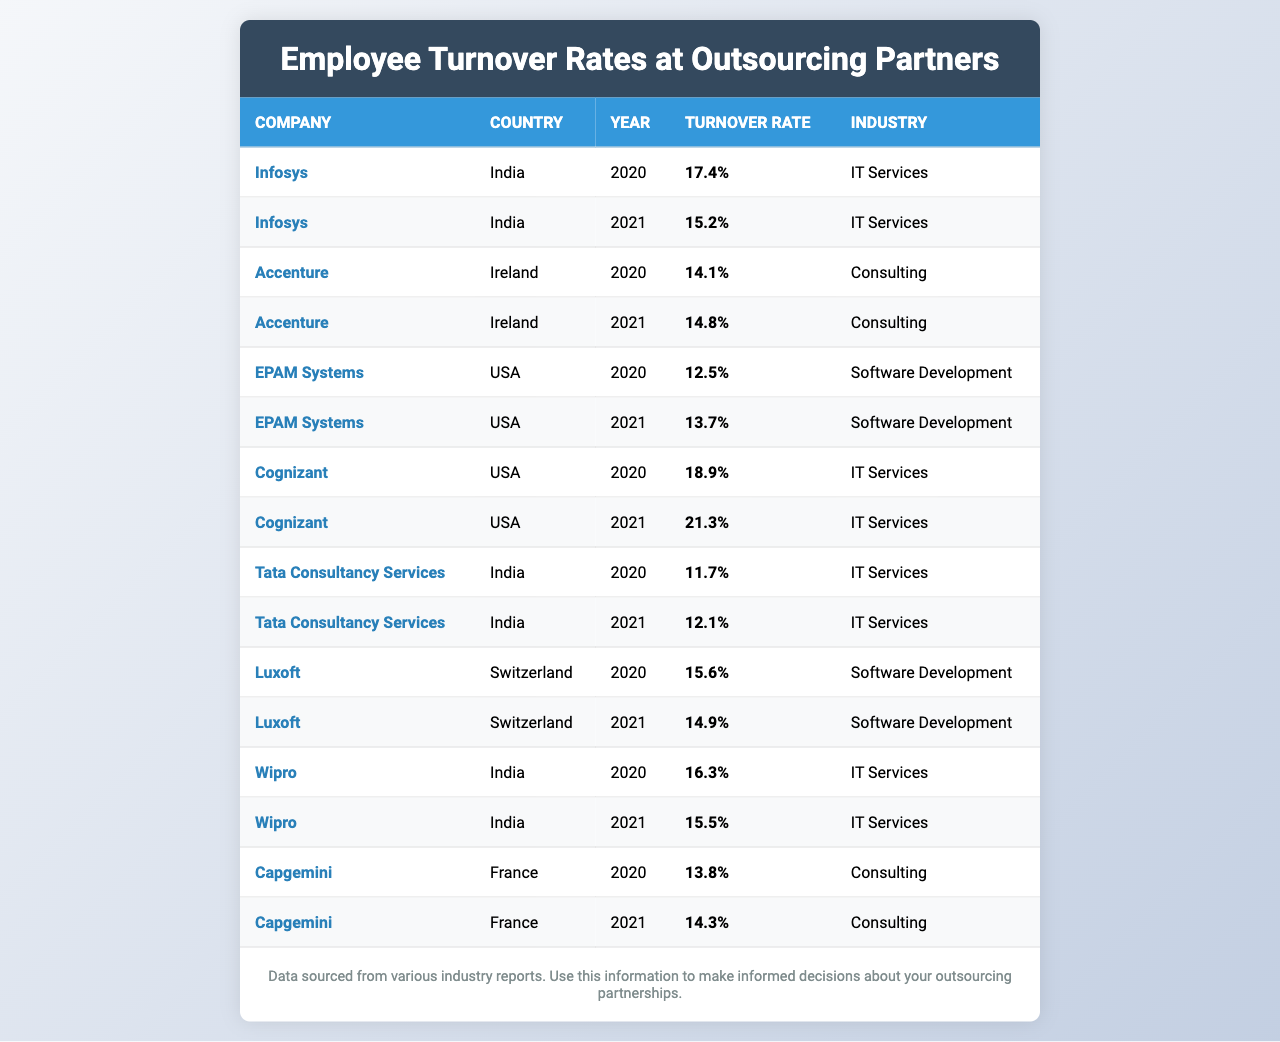What is the turnover rate for Tata Consultancy Services in 2021? The table lists Tata Consultancy Services with a turnover rate of 12.1% for the year 2021.
Answer: 12.1% Which company had the highest turnover rate in 2020? By examining the table, Cognizant shows the highest turnover rate of 18.9% in the year 2020.
Answer: Cognizant What is the average turnover rate for Accenture over the years provided? Adding Accenture's turnover rates for 2020 (14.1%) and 2021 (14.8%) gives 28.9%. Dividing by 2 gives an average of 14.45%.
Answer: 14.45% Did Infosys experience an increase or decrease in turnover rate from 2020 to 2021? The turnover rate for Infosys dropped from 17.4% in 2020 to 15.2% in 2021, indicating a decrease.
Answer: Decrease Which country has the lowest average turnover rate based on the table? The average turnover rates by country are: India (15.36%), Ireland (14.45%), USA (16.1%), Switzerland (15.25%). The lowest average is from Ireland at 14.45%.
Answer: Ireland What was the change in turnover rate for EPAM Systems from 2020 to 2021? EPAM Systems' turnover increased from 12.5% in 2020 to 13.7% in 2021, resulting in a change of 1.2%.
Answer: 1.2% Is the turnover rate for Cognizant higher or lower than that of Luxoft in 2021? Cognizant's turnover rate in 2021 is 21.3%, which is higher than Luxoft's rate of 14.9% for the same year.
Answer: Higher Which company had a stable turnover rate between the two years? Tata Consultancy Services showed only a slight increase from 11.7% in 2020 to 12.1% in 2021, indicating stability.
Answer: Tata Consultancy Services What is the difference in turnover rates between the highest and lowest for 2020? The highest turnover rate in 2020 was 18.9% (Cognizant) and the lowest was 11.7% (Tata Consultancy Services). The difference is 18.9% - 11.7% = 7.2%.
Answer: 7.2% Are there any companies with a turnover rate below 15% in 2021? In 2021, the companies EPAM Systems (13.7%) and Luxoft (14.9%) both had turnover rates below 15%.
Answer: Yes 